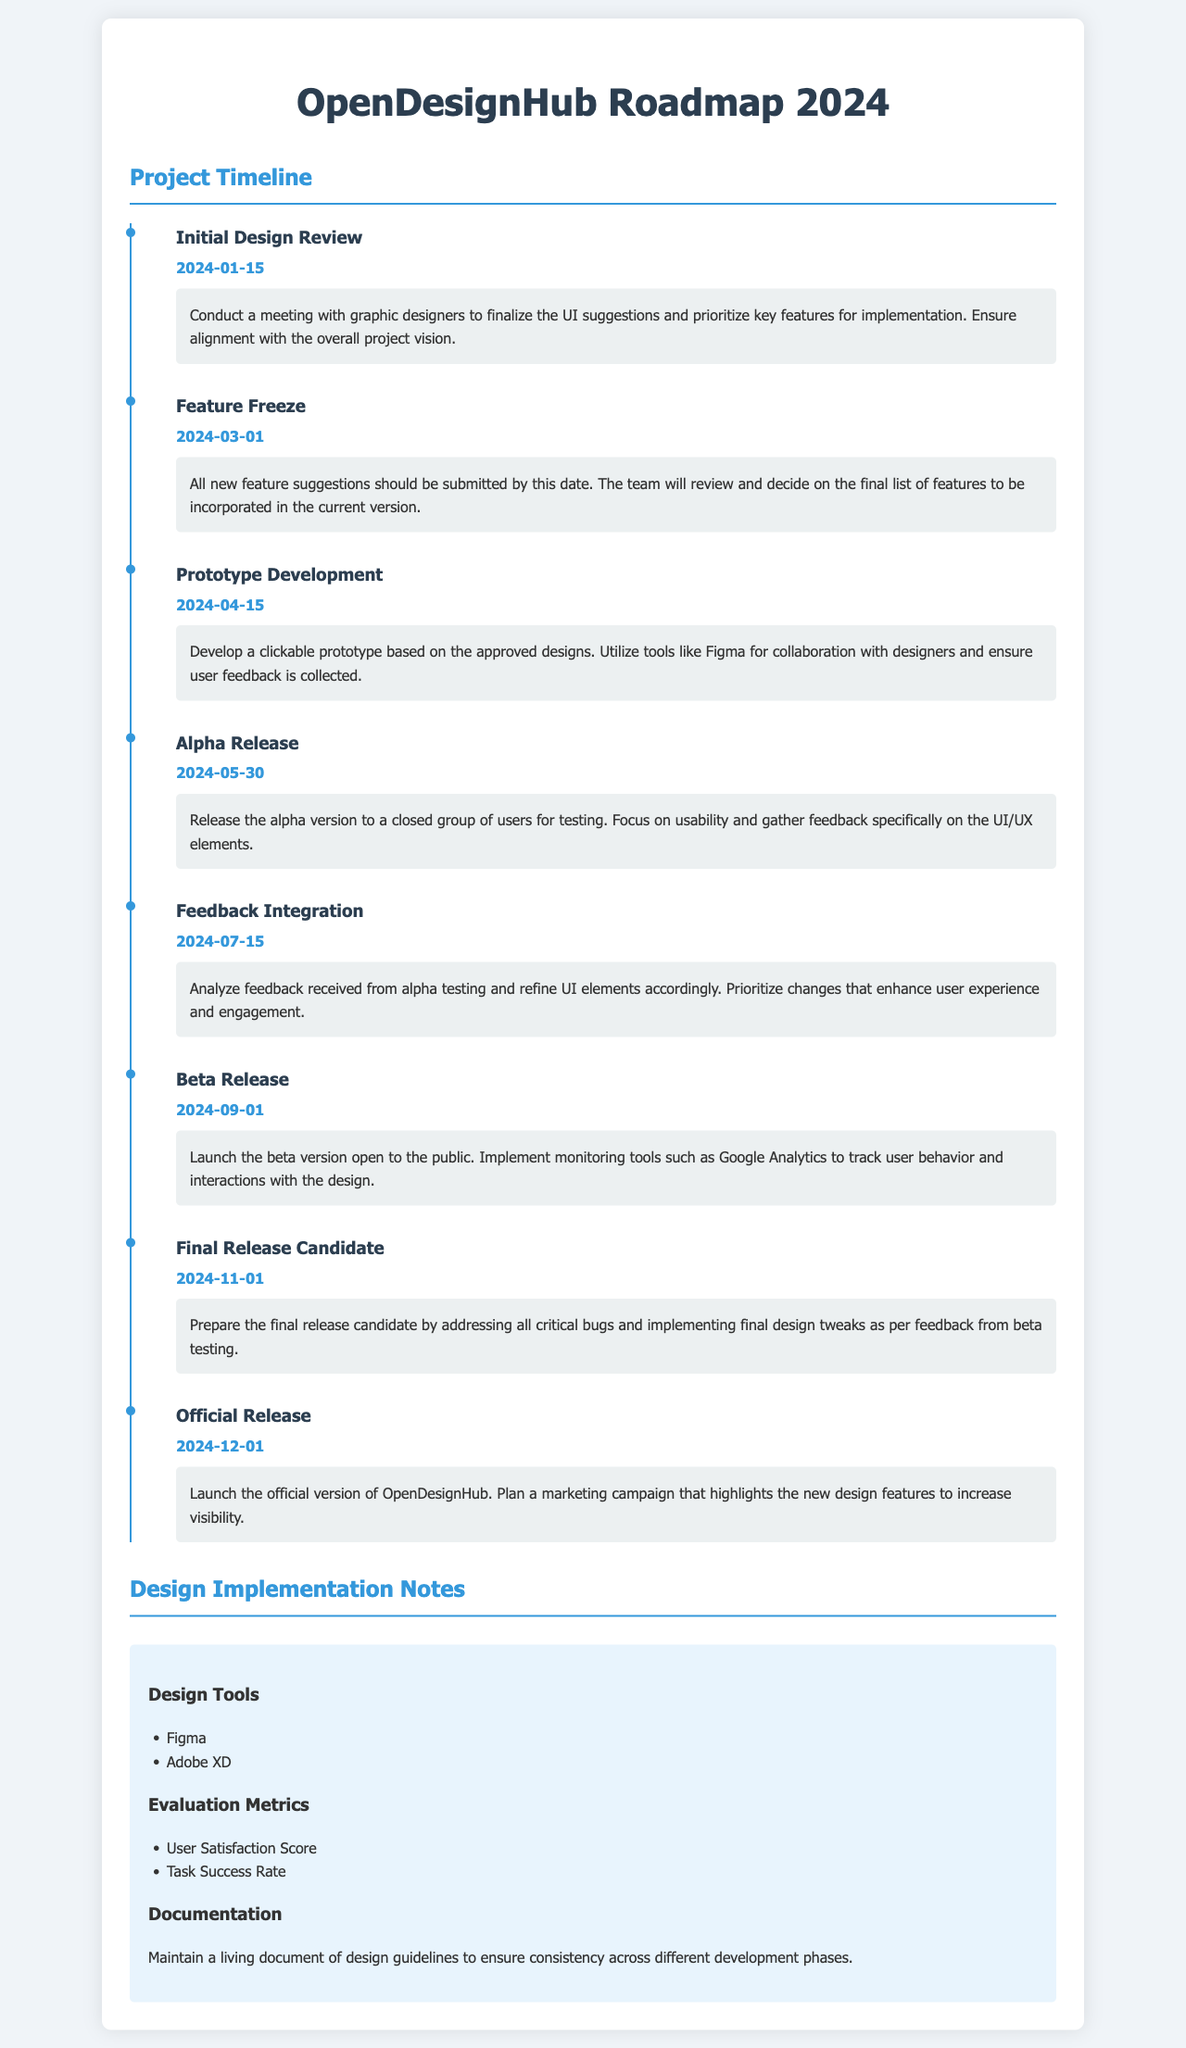What is the date of the Initial Design Review? The Initial Design Review is scheduled for January 15, 2024.
Answer: January 15, 2024 When is the Feature Freeze deadline? The Feature Freeze deadline is March 1, 2024.
Answer: March 1, 2024 What is the purpose of the Alpha Release? The purpose of the Alpha Release is to release the alpha version to a closed group of users for testing.
Answer: Usability testing What is the date set for the Beta Release? The Beta Release is scheduled for September 1, 2024.
Answer: September 1, 2024 Which design tool is mentioned for collaboration? Figma is mentioned as a design tool for collaboration.
Answer: Figma What should be prepared before the Final Release Candidate? All critical bugs should be addressed before the Final Release Candidate.
Answer: Critical bugs What type of document is being outlined in this roadmap? This document outlines the OpenDesignHub roadmap for 2024.
Answer: Roadmap What should be maintained according to the Documentation section? A living document of design guidelines should be maintained.
Answer: Design guidelines 